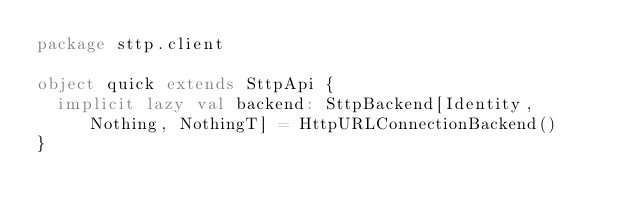<code> <loc_0><loc_0><loc_500><loc_500><_Scala_>package sttp.client

object quick extends SttpApi {
  implicit lazy val backend: SttpBackend[Identity, Nothing, NothingT] = HttpURLConnectionBackend()
}
</code> 